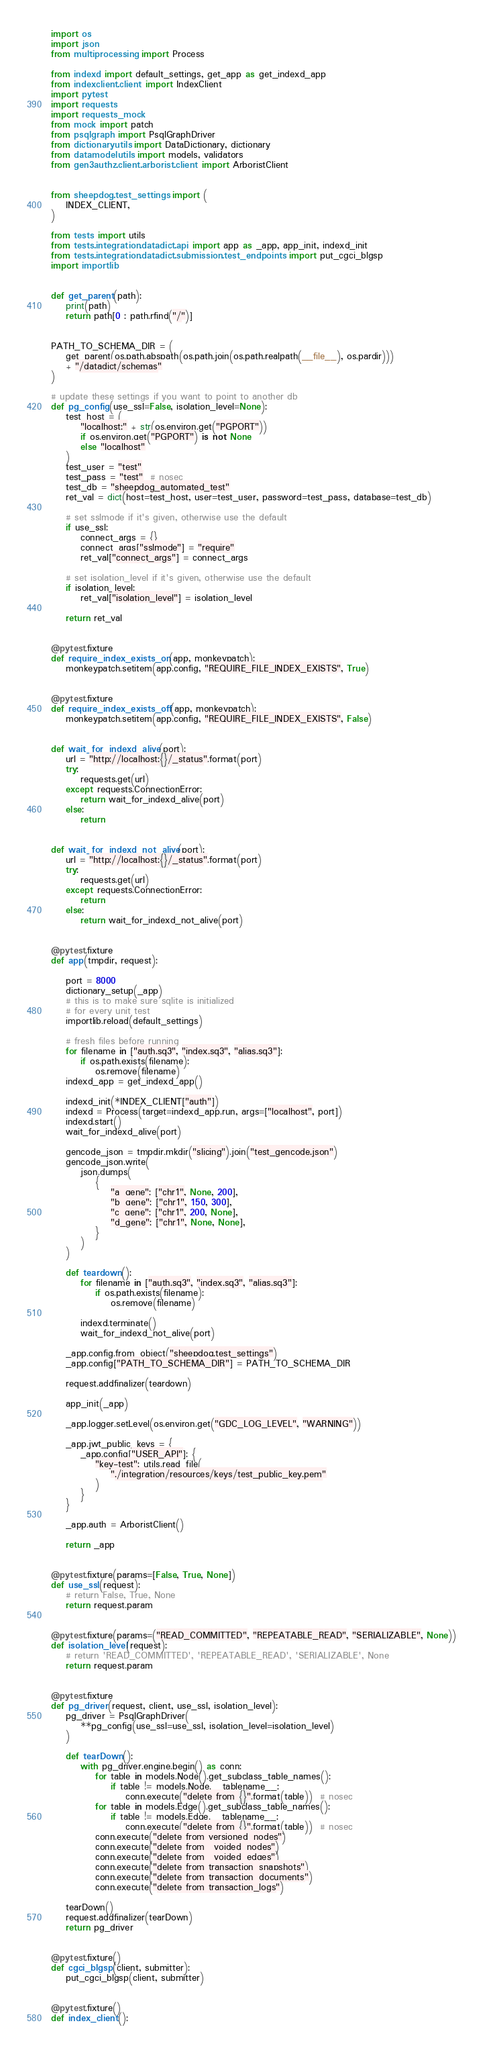Convert code to text. <code><loc_0><loc_0><loc_500><loc_500><_Python_>import os
import json
from multiprocessing import Process

from indexd import default_settings, get_app as get_indexd_app
from indexclient.client import IndexClient
import pytest
import requests
import requests_mock
from mock import patch
from psqlgraph import PsqlGraphDriver
from dictionaryutils import DataDictionary, dictionary
from datamodelutils import models, validators
from gen3authz.client.arborist.client import ArboristClient


from sheepdog.test_settings import (
    INDEX_CLIENT,
)

from tests import utils
from tests.integration.datadict.api import app as _app, app_init, indexd_init
from tests.integration.datadict.submission.test_endpoints import put_cgci_blgsp
import importlib


def get_parent(path):
    print(path)
    return path[0 : path.rfind("/")]


PATH_TO_SCHEMA_DIR = (
    get_parent(os.path.abspath(os.path.join(os.path.realpath(__file__), os.pardir)))
    + "/datadict/schemas"
)

# update these settings if you want to point to another db
def pg_config(use_ssl=False, isolation_level=None):
    test_host = (
        "localhost:" + str(os.environ.get("PGPORT"))
        if os.environ.get("PGPORT") is not None
        else "localhost"
    )
    test_user = "test"
    test_pass = "test"  # nosec
    test_db = "sheepdog_automated_test"
    ret_val = dict(host=test_host, user=test_user, password=test_pass, database=test_db)

    # set sslmode if it's given, otherwise use the default
    if use_ssl:
        connect_args = {}
        connect_args["sslmode"] = "require"
        ret_val["connect_args"] = connect_args

    # set isolation_level if it's given, otherwise use the default
    if isolation_level:
        ret_val["isolation_level"] = isolation_level

    return ret_val


@pytest.fixture
def require_index_exists_on(app, monkeypatch):
    monkeypatch.setitem(app.config, "REQUIRE_FILE_INDEX_EXISTS", True)


@pytest.fixture
def require_index_exists_off(app, monkeypatch):
    monkeypatch.setitem(app.config, "REQUIRE_FILE_INDEX_EXISTS", False)


def wait_for_indexd_alive(port):
    url = "http://localhost:{}/_status".format(port)
    try:
        requests.get(url)
    except requests.ConnectionError:
        return wait_for_indexd_alive(port)
    else:
        return


def wait_for_indexd_not_alive(port):
    url = "http://localhost:{}/_status".format(port)
    try:
        requests.get(url)
    except requests.ConnectionError:
        return
    else:
        return wait_for_indexd_not_alive(port)


@pytest.fixture
def app(tmpdir, request):

    port = 8000
    dictionary_setup(_app)
    # this is to make sure sqlite is initialized
    # for every unit test
    importlib.reload(default_settings)

    # fresh files before running
    for filename in ["auth.sq3", "index.sq3", "alias.sq3"]:
        if os.path.exists(filename):
            os.remove(filename)
    indexd_app = get_indexd_app()

    indexd_init(*INDEX_CLIENT["auth"])
    indexd = Process(target=indexd_app.run, args=["localhost", port])
    indexd.start()
    wait_for_indexd_alive(port)

    gencode_json = tmpdir.mkdir("slicing").join("test_gencode.json")
    gencode_json.write(
        json.dumps(
            {
                "a_gene": ["chr1", None, 200],
                "b_gene": ["chr1", 150, 300],
                "c_gene": ["chr1", 200, None],
                "d_gene": ["chr1", None, None],
            }
        )
    )

    def teardown():
        for filename in ["auth.sq3", "index.sq3", "alias.sq3"]:
            if os.path.exists(filename):
                os.remove(filename)

        indexd.terminate()
        wait_for_indexd_not_alive(port)

    _app.config.from_object("sheepdog.test_settings")
    _app.config["PATH_TO_SCHEMA_DIR"] = PATH_TO_SCHEMA_DIR

    request.addfinalizer(teardown)

    app_init(_app)

    _app.logger.setLevel(os.environ.get("GDC_LOG_LEVEL", "WARNING"))

    _app.jwt_public_keys = {
        _app.config["USER_API"]: {
            "key-test": utils.read_file(
                "./integration/resources/keys/test_public_key.pem"
            )
        }
    }

    _app.auth = ArboristClient()

    return _app


@pytest.fixture(params=[False, True, None])
def use_ssl(request):
    # return False, True, None
    return request.param


@pytest.fixture(params=("READ_COMMITTED", "REPEATABLE_READ", "SERIALIZABLE", None))
def isolation_level(request):
    # return 'READ_COMMITTED', 'REPEATABLE_READ', 'SERIALIZABLE', None
    return request.param


@pytest.fixture
def pg_driver(request, client, use_ssl, isolation_level):
    pg_driver = PsqlGraphDriver(
        **pg_config(use_ssl=use_ssl, isolation_level=isolation_level)
    )

    def tearDown():
        with pg_driver.engine.begin() as conn:
            for table in models.Node().get_subclass_table_names():
                if table != models.Node.__tablename__:
                    conn.execute("delete from {}".format(table))  # nosec
            for table in models.Edge().get_subclass_table_names():
                if table != models.Edge.__tablename__:
                    conn.execute("delete from {}".format(table))  # nosec
            conn.execute("delete from versioned_nodes")
            conn.execute("delete from _voided_nodes")
            conn.execute("delete from _voided_edges")
            conn.execute("delete from transaction_snapshots")
            conn.execute("delete from transaction_documents")
            conn.execute("delete from transaction_logs")

    tearDown()
    request.addfinalizer(tearDown)
    return pg_driver


@pytest.fixture()
def cgci_blgsp(client, submitter):
    put_cgci_blgsp(client, submitter)


@pytest.fixture()
def index_client():</code> 